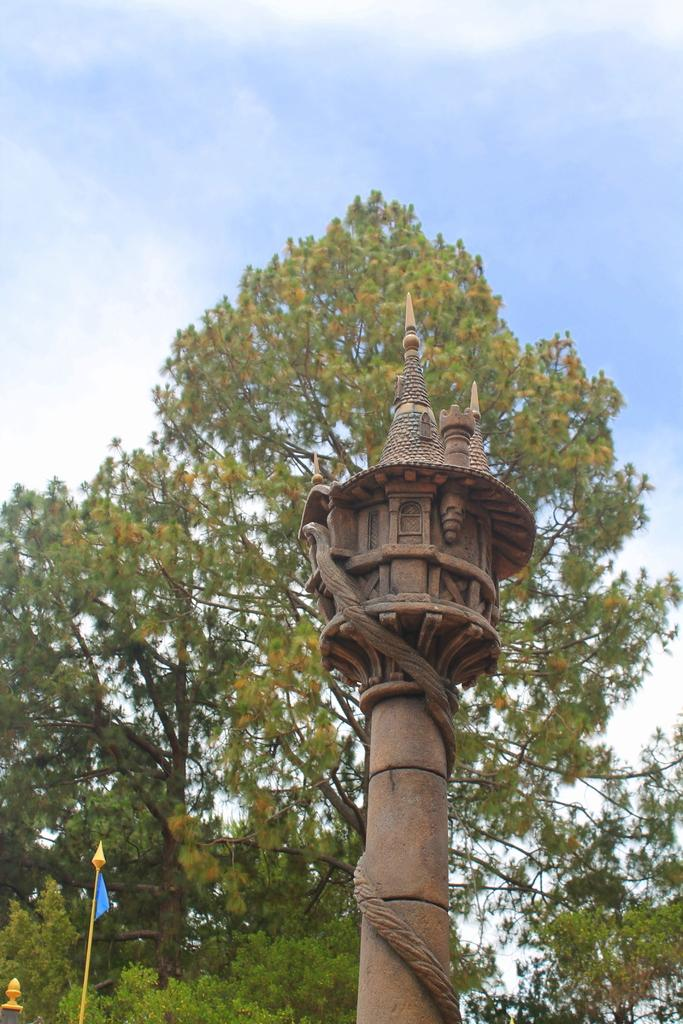What is located in the front of the image? There is a pole in the front of the image. What can be seen in the background of the image? There is a tree in the background of the image. What is visible at the top of the image? The sky is visible at the top of the image. How many dogs are sitting on the square in the image? There are no dogs or squares present in the image. What thoughts are going through the mind of the tree in the image? Trees do not have minds, and there is no indication of any thoughts in the image. 